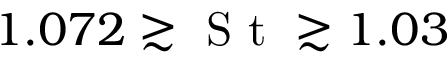Convert formula to latex. <formula><loc_0><loc_0><loc_500><loc_500>1 . 0 7 2 \gtrsim S t \gtrsim 1 . 0 3</formula> 